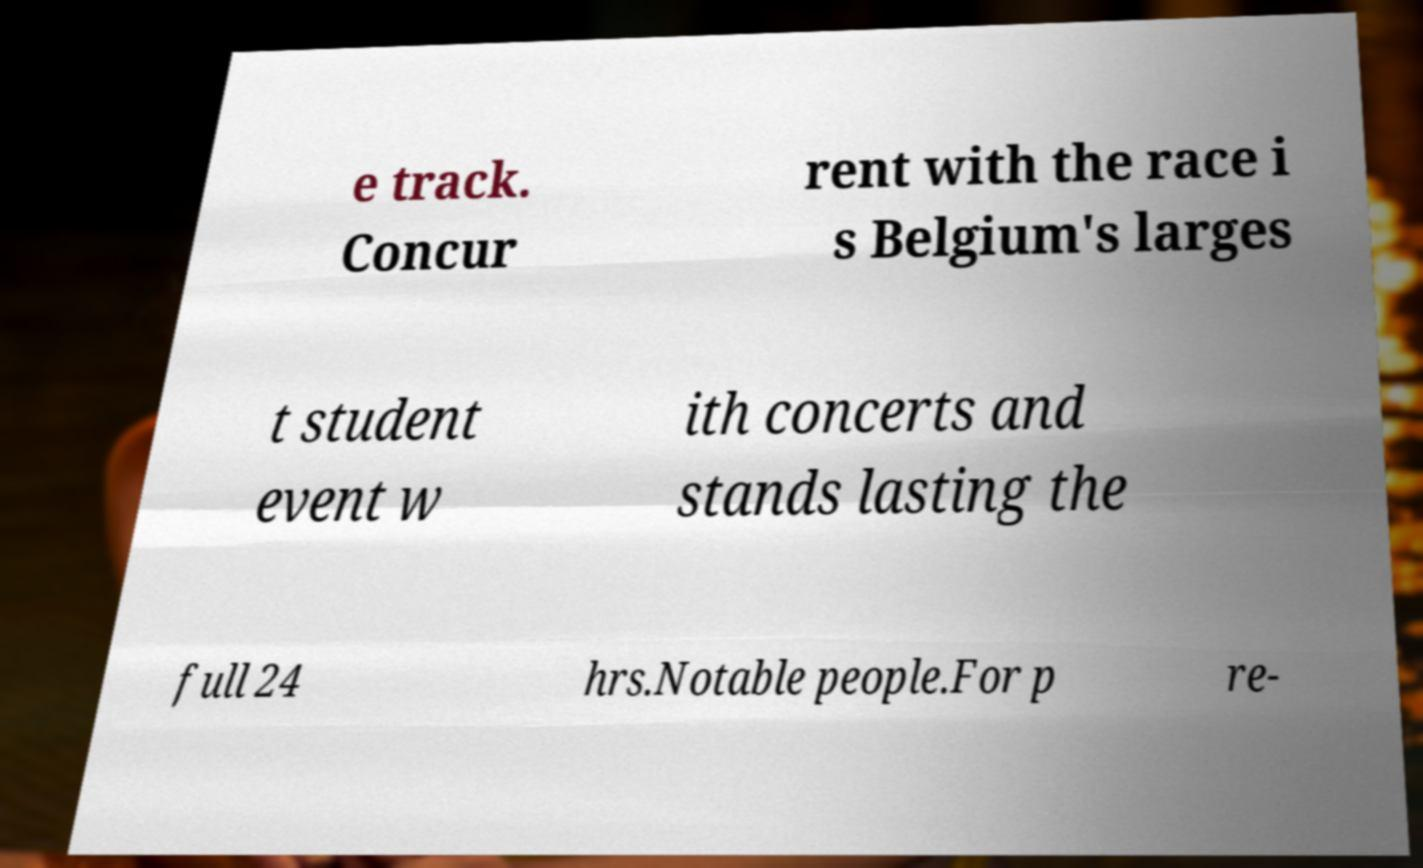Please read and relay the text visible in this image. What does it say? e track. Concur rent with the race i s Belgium's larges t student event w ith concerts and stands lasting the full 24 hrs.Notable people.For p re- 